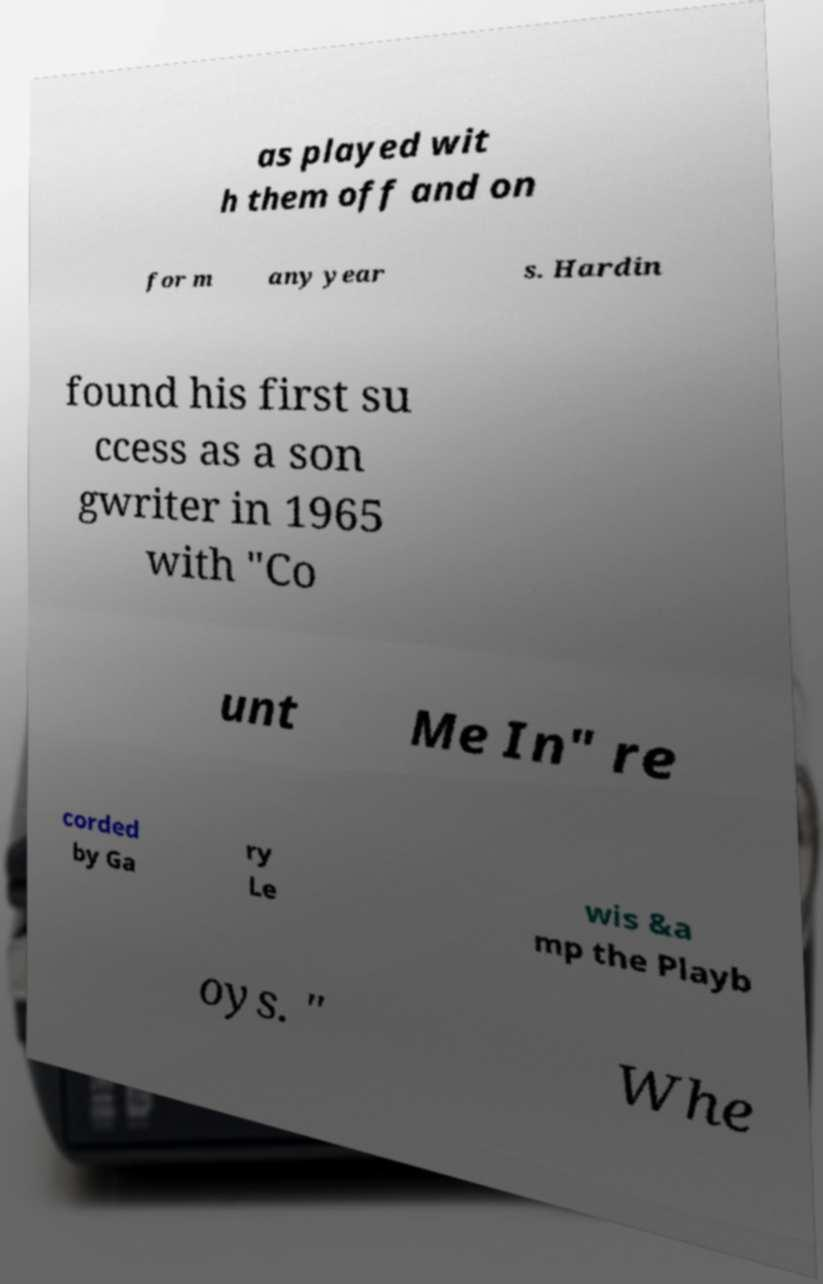Please identify and transcribe the text found in this image. as played wit h them off and on for m any year s. Hardin found his first su ccess as a son gwriter in 1965 with "Co unt Me In" re corded by Ga ry Le wis &a mp the Playb oys. " Whe 